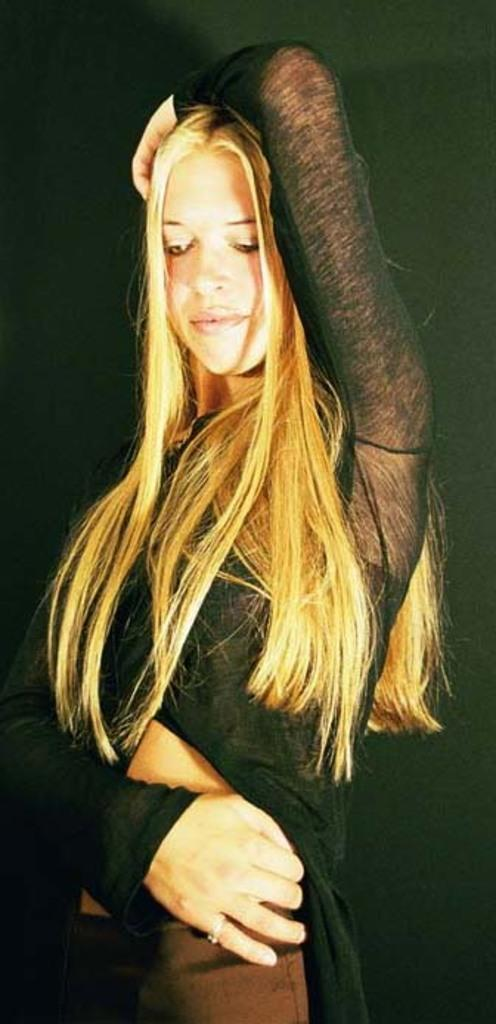Who is the main subject in the image? There is a woman in the image. What is a distinctive feature of the woman's appearance? The woman has blond hair. What is the woman wearing? The woman is wearing a black dress. What is the woman doing in the image? The woman is standing. What can be observed about the background of the image? The background of the image is dark. How many yaks are present in the image? There are no yaks present in the image; it features a woman with blond hair wearing a black dress. What type of addition problem can be solved using the cherries in the image? There are no cherries present in the image, so no addition problem can be solved using them. 